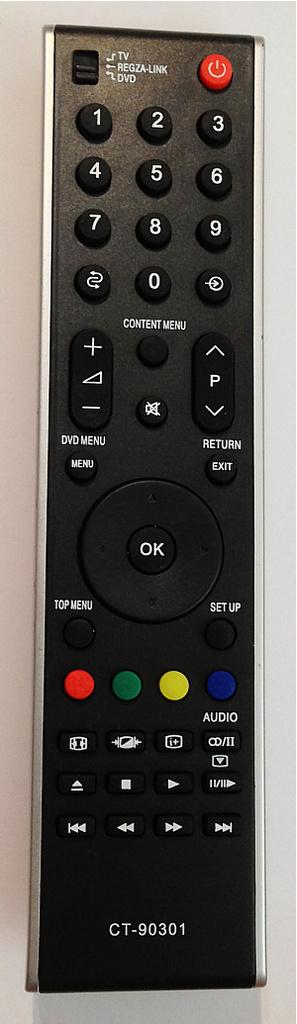<image>
Render a clear and concise summary of the photo. A remote control labeled CT-90301 lays on a white surface. 